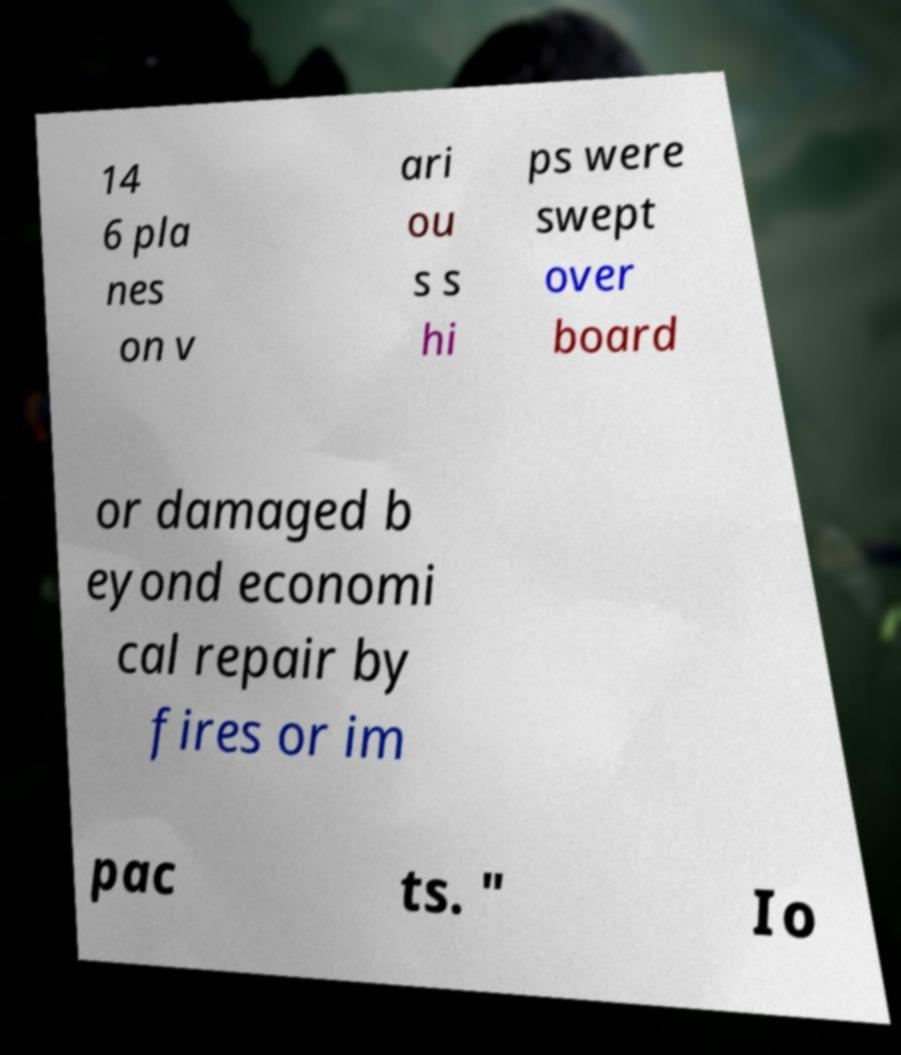Please identify and transcribe the text found in this image. 14 6 pla nes on v ari ou s s hi ps were swept over board or damaged b eyond economi cal repair by fires or im pac ts. " Io 